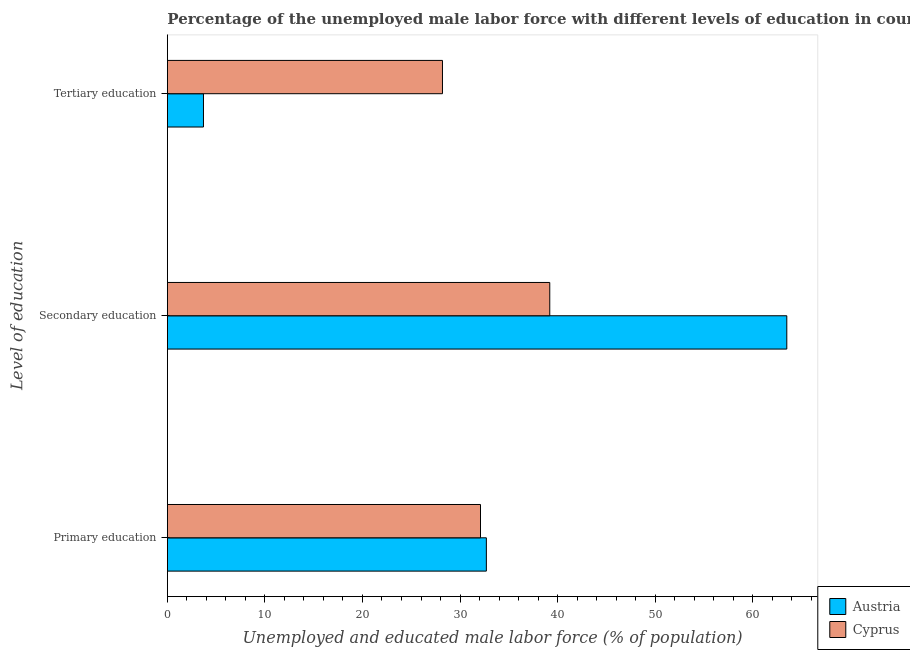How many groups of bars are there?
Make the answer very short. 3. Are the number of bars on each tick of the Y-axis equal?
Your response must be concise. Yes. How many bars are there on the 3rd tick from the top?
Your answer should be compact. 2. How many bars are there on the 2nd tick from the bottom?
Your response must be concise. 2. What is the label of the 2nd group of bars from the top?
Offer a terse response. Secondary education. What is the percentage of male labor force who received tertiary education in Austria?
Offer a terse response. 3.7. Across all countries, what is the maximum percentage of male labor force who received secondary education?
Ensure brevity in your answer.  63.5. Across all countries, what is the minimum percentage of male labor force who received tertiary education?
Your response must be concise. 3.7. In which country was the percentage of male labor force who received primary education minimum?
Make the answer very short. Cyprus. What is the total percentage of male labor force who received tertiary education in the graph?
Offer a terse response. 31.9. What is the difference between the percentage of male labor force who received secondary education in Cyprus and that in Austria?
Ensure brevity in your answer.  -24.3. What is the difference between the percentage of male labor force who received secondary education in Austria and the percentage of male labor force who received tertiary education in Cyprus?
Provide a succinct answer. 35.3. What is the average percentage of male labor force who received secondary education per country?
Offer a terse response. 51.35. What is the difference between the percentage of male labor force who received tertiary education and percentage of male labor force who received primary education in Cyprus?
Provide a short and direct response. -3.9. What is the ratio of the percentage of male labor force who received tertiary education in Austria to that in Cyprus?
Your answer should be very brief. 0.13. Is the percentage of male labor force who received primary education in Cyprus less than that in Austria?
Your answer should be compact. Yes. Is the difference between the percentage of male labor force who received primary education in Cyprus and Austria greater than the difference between the percentage of male labor force who received secondary education in Cyprus and Austria?
Provide a succinct answer. Yes. What is the difference between the highest and the second highest percentage of male labor force who received primary education?
Provide a succinct answer. 0.6. What is the difference between the highest and the lowest percentage of male labor force who received tertiary education?
Your answer should be compact. 24.5. In how many countries, is the percentage of male labor force who received primary education greater than the average percentage of male labor force who received primary education taken over all countries?
Keep it short and to the point. 1. What does the 1st bar from the top in Secondary education represents?
Keep it short and to the point. Cyprus. What does the 2nd bar from the bottom in Secondary education represents?
Offer a terse response. Cyprus. Is it the case that in every country, the sum of the percentage of male labor force who received primary education and percentage of male labor force who received secondary education is greater than the percentage of male labor force who received tertiary education?
Keep it short and to the point. Yes. How many bars are there?
Give a very brief answer. 6. What is the difference between two consecutive major ticks on the X-axis?
Provide a succinct answer. 10. How are the legend labels stacked?
Ensure brevity in your answer.  Vertical. What is the title of the graph?
Ensure brevity in your answer.  Percentage of the unemployed male labor force with different levels of education in countries. What is the label or title of the X-axis?
Provide a succinct answer. Unemployed and educated male labor force (% of population). What is the label or title of the Y-axis?
Give a very brief answer. Level of education. What is the Unemployed and educated male labor force (% of population) of Austria in Primary education?
Give a very brief answer. 32.7. What is the Unemployed and educated male labor force (% of population) of Cyprus in Primary education?
Your response must be concise. 32.1. What is the Unemployed and educated male labor force (% of population) in Austria in Secondary education?
Provide a succinct answer. 63.5. What is the Unemployed and educated male labor force (% of population) in Cyprus in Secondary education?
Give a very brief answer. 39.2. What is the Unemployed and educated male labor force (% of population) in Austria in Tertiary education?
Your response must be concise. 3.7. What is the Unemployed and educated male labor force (% of population) in Cyprus in Tertiary education?
Offer a very short reply. 28.2. Across all Level of education, what is the maximum Unemployed and educated male labor force (% of population) in Austria?
Your response must be concise. 63.5. Across all Level of education, what is the maximum Unemployed and educated male labor force (% of population) in Cyprus?
Provide a succinct answer. 39.2. Across all Level of education, what is the minimum Unemployed and educated male labor force (% of population) of Austria?
Give a very brief answer. 3.7. Across all Level of education, what is the minimum Unemployed and educated male labor force (% of population) in Cyprus?
Ensure brevity in your answer.  28.2. What is the total Unemployed and educated male labor force (% of population) of Austria in the graph?
Offer a very short reply. 99.9. What is the total Unemployed and educated male labor force (% of population) of Cyprus in the graph?
Offer a terse response. 99.5. What is the difference between the Unemployed and educated male labor force (% of population) of Austria in Primary education and that in Secondary education?
Give a very brief answer. -30.8. What is the difference between the Unemployed and educated male labor force (% of population) in Austria in Primary education and that in Tertiary education?
Offer a very short reply. 29. What is the difference between the Unemployed and educated male labor force (% of population) in Cyprus in Primary education and that in Tertiary education?
Your answer should be compact. 3.9. What is the difference between the Unemployed and educated male labor force (% of population) of Austria in Secondary education and that in Tertiary education?
Give a very brief answer. 59.8. What is the difference between the Unemployed and educated male labor force (% of population) in Cyprus in Secondary education and that in Tertiary education?
Give a very brief answer. 11. What is the difference between the Unemployed and educated male labor force (% of population) in Austria in Secondary education and the Unemployed and educated male labor force (% of population) in Cyprus in Tertiary education?
Ensure brevity in your answer.  35.3. What is the average Unemployed and educated male labor force (% of population) in Austria per Level of education?
Keep it short and to the point. 33.3. What is the average Unemployed and educated male labor force (% of population) in Cyprus per Level of education?
Offer a very short reply. 33.17. What is the difference between the Unemployed and educated male labor force (% of population) of Austria and Unemployed and educated male labor force (% of population) of Cyprus in Secondary education?
Ensure brevity in your answer.  24.3. What is the difference between the Unemployed and educated male labor force (% of population) of Austria and Unemployed and educated male labor force (% of population) of Cyprus in Tertiary education?
Offer a very short reply. -24.5. What is the ratio of the Unemployed and educated male labor force (% of population) of Austria in Primary education to that in Secondary education?
Provide a succinct answer. 0.52. What is the ratio of the Unemployed and educated male labor force (% of population) in Cyprus in Primary education to that in Secondary education?
Your answer should be compact. 0.82. What is the ratio of the Unemployed and educated male labor force (% of population) in Austria in Primary education to that in Tertiary education?
Your answer should be compact. 8.84. What is the ratio of the Unemployed and educated male labor force (% of population) of Cyprus in Primary education to that in Tertiary education?
Make the answer very short. 1.14. What is the ratio of the Unemployed and educated male labor force (% of population) of Austria in Secondary education to that in Tertiary education?
Give a very brief answer. 17.16. What is the ratio of the Unemployed and educated male labor force (% of population) of Cyprus in Secondary education to that in Tertiary education?
Keep it short and to the point. 1.39. What is the difference between the highest and the second highest Unemployed and educated male labor force (% of population) in Austria?
Keep it short and to the point. 30.8. What is the difference between the highest and the lowest Unemployed and educated male labor force (% of population) in Austria?
Offer a terse response. 59.8. 